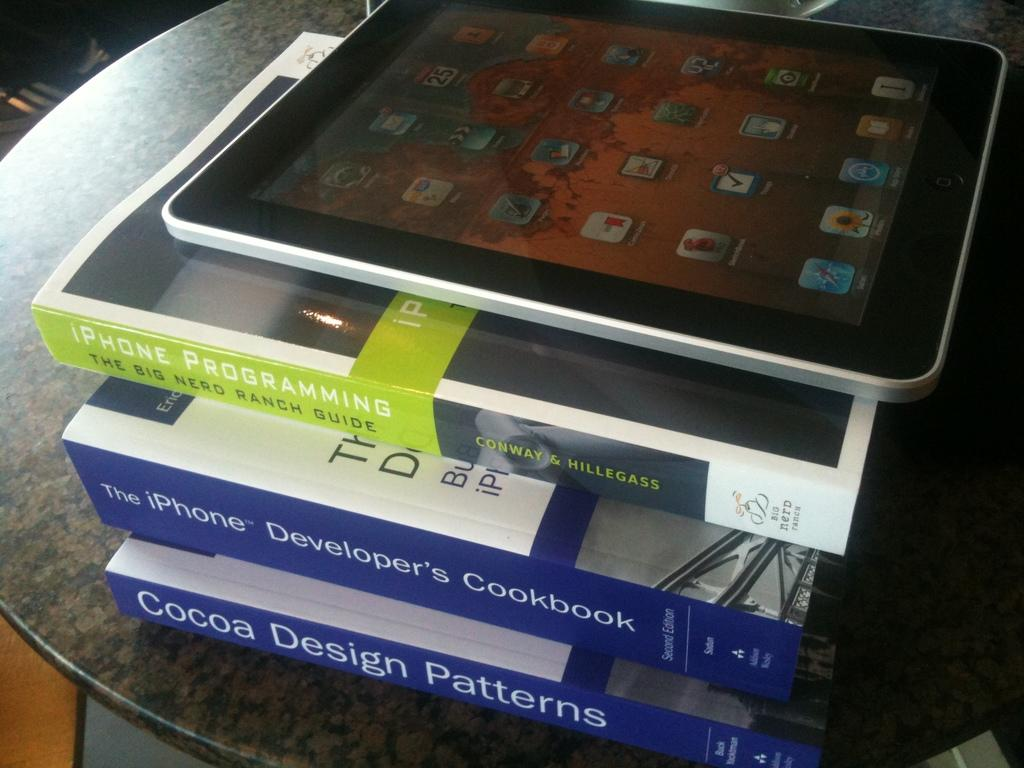<image>
Provide a brief description of the given image. A stack of books about iPhone with an Apple iPad on top. 